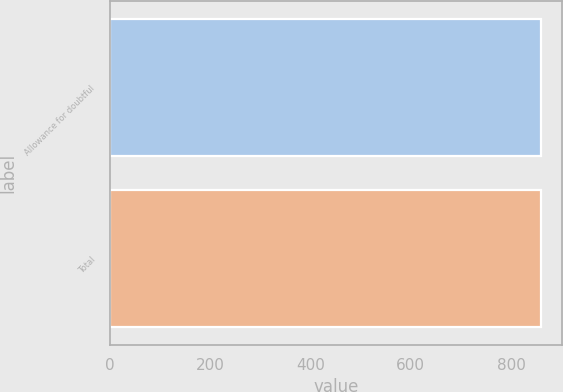<chart> <loc_0><loc_0><loc_500><loc_500><bar_chart><fcel>Allowance for doubtful<fcel>Total<nl><fcel>859<fcel>859.1<nl></chart> 